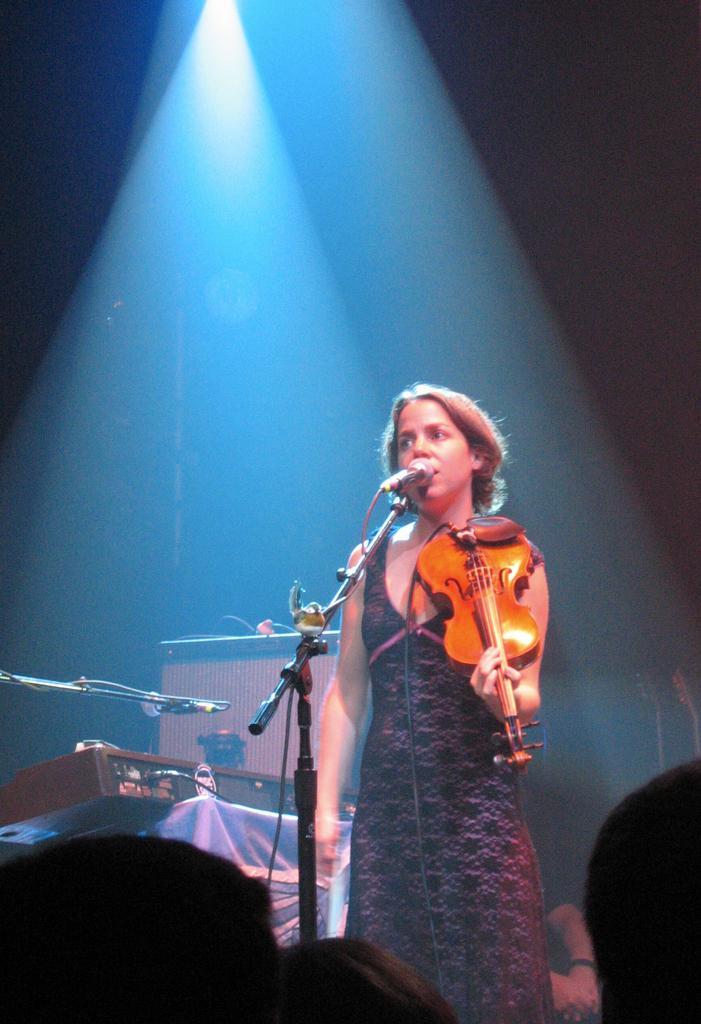Can you describe this image briefly? In the image there is a girl playing a violin and singing on mic and beside her there are other music instruments and light is focusing on the top to her. 